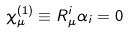Convert formula to latex. <formula><loc_0><loc_0><loc_500><loc_500>\chi ^ { ( 1 ) } _ { \mu } \equiv R _ { \mu } ^ { i } \alpha _ { i } = 0</formula> 